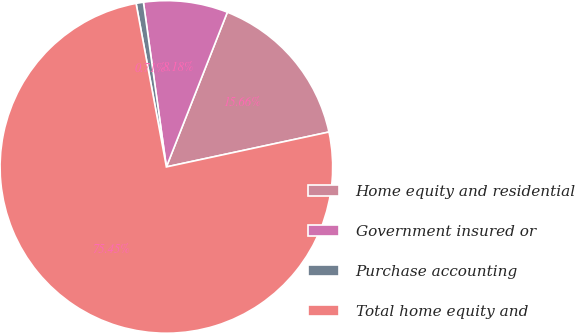Convert chart to OTSL. <chart><loc_0><loc_0><loc_500><loc_500><pie_chart><fcel>Home equity and residential<fcel>Government insured or<fcel>Purchase accounting<fcel>Total home equity and<nl><fcel>15.66%<fcel>8.18%<fcel>0.71%<fcel>75.45%<nl></chart> 